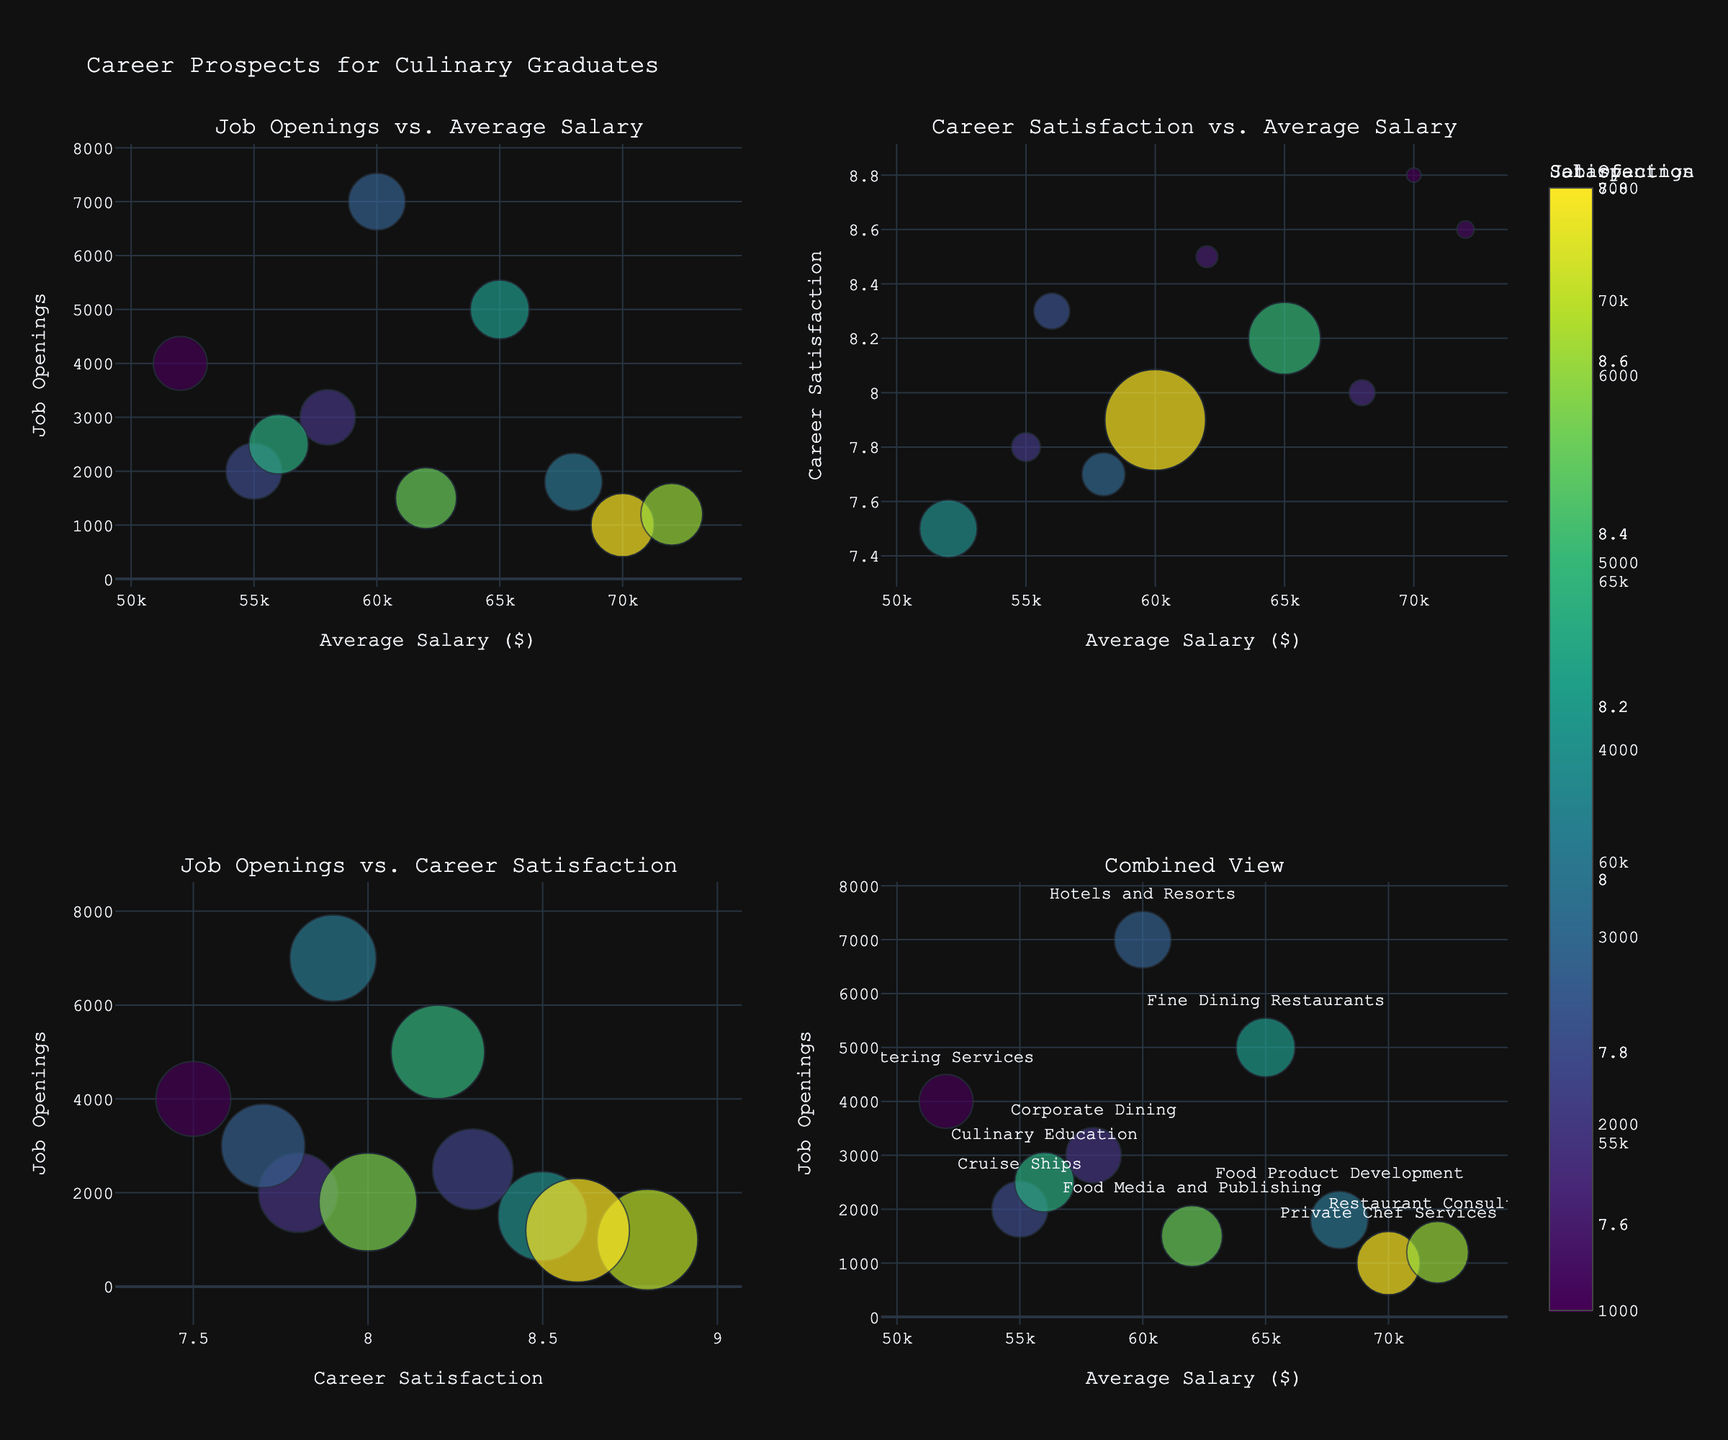How many sectors are represented in the charts? There are specific data points plotted on each bubble chart. Each bubble corresponds to a sector. By counting the unique bubbles, we can determine the number of sectors.
Answer: 10 Which sector has the highest career satisfaction? In the bubble chart, identify the largest bubbles in Plot 1 or Plot 4, where the Career Satisfaction determines the bubble size. The largest bubble should represent the sector with the highest career satisfaction.
Answer: Private Chef Services What is the range of average salaries represented? Analyze the x-axis of the plots titled "Job Openings vs. Average Salary" and "Career Satisfaction vs. Average Salary." Check the minimum and maximum values on the x-axis to find the range of average salaries.
Answer: $52,000 - $72,000 Which sector has the most job openings? In the "Job Openings vs. Average Salary" and "Job Openings vs. Career Satisfaction" plots, identify the bubble positioned highest on the y-axis (job openings axis).
Answer: Hotels and Resorts Compare the average salary and career satisfaction between Food Media and Publishing and Private Chef Services sectors. Which one ranks higher on both metrics? Locate both sectors on the plot that shows Career Satisfaction vs. Average Salary. Compare their positions along the x-axis (average salary) and y-axis (career satisfaction).
Answer: Private Chef Services ranks higher on both In the "Combined View" plot, identify the sector with the second-largest career satisfaction. In the "Combined View" plot, find the second-largest bubble, since bubble size correlates with career satisfaction. Hover or refer to the label to determine the sector.
Answer: Restaurant Consulting In which plot do bubble sizes represent job openings? Bubble sizes in each plot represent different metrics. In the "Career Satisfaction vs. Average Salary" plot, bubble sizes represent job openings.
Answer: Career Satisfaction vs. Average Salary Identify a sector with an average salary greater than $60,000 and at least 7.9 career satisfaction that has fewer than 2000 job openings. Filter the sectors based on the given criteria and locate the matching bubbles on the respective charts. Food Media and Publishing fits these conditions.
Answer: Food Media and Publishing What is the correlation between average salary and job openings based on the top-left plot? Observing the plot titled "Job Openings vs. Average Salary," analyze the overall distribution and trend of the bubbles.
Answer: There is no clear correlation Is there a sector with a higher average salary than Corporate Dining but with lower career satisfaction? To answer this, compare the sectors in terms of average salary (x-axis) and career satisfaction (bubble sizes) in the respective plots.
Answer: Yes, Food Product Development 